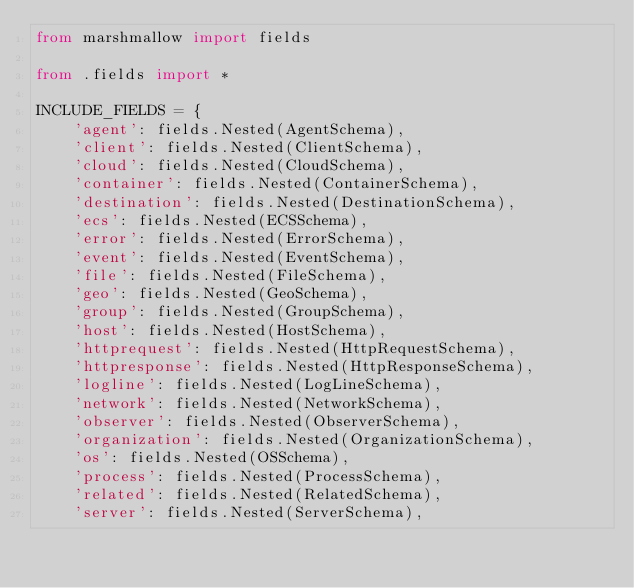Convert code to text. <code><loc_0><loc_0><loc_500><loc_500><_Python_>from marshmallow import fields

from .fields import *

INCLUDE_FIELDS = {
    'agent': fields.Nested(AgentSchema),
    'client': fields.Nested(ClientSchema),
    'cloud': fields.Nested(CloudSchema),
    'container': fields.Nested(ContainerSchema),
    'destination': fields.Nested(DestinationSchema),
    'ecs': fields.Nested(ECSSchema),
    'error': fields.Nested(ErrorSchema),
    'event': fields.Nested(EventSchema),
    'file': fields.Nested(FileSchema),
    'geo': fields.Nested(GeoSchema),
    'group': fields.Nested(GroupSchema),
    'host': fields.Nested(HostSchema),
    'httprequest': fields.Nested(HttpRequestSchema),
    'httpresponse': fields.Nested(HttpResponseSchema),
    'logline': fields.Nested(LogLineSchema),
    'network': fields.Nested(NetworkSchema),
    'observer': fields.Nested(ObserverSchema),
    'organization': fields.Nested(OrganizationSchema),
    'os': fields.Nested(OSSchema),
    'process': fields.Nested(ProcessSchema),
    'related': fields.Nested(RelatedSchema),
    'server': fields.Nested(ServerSchema),</code> 